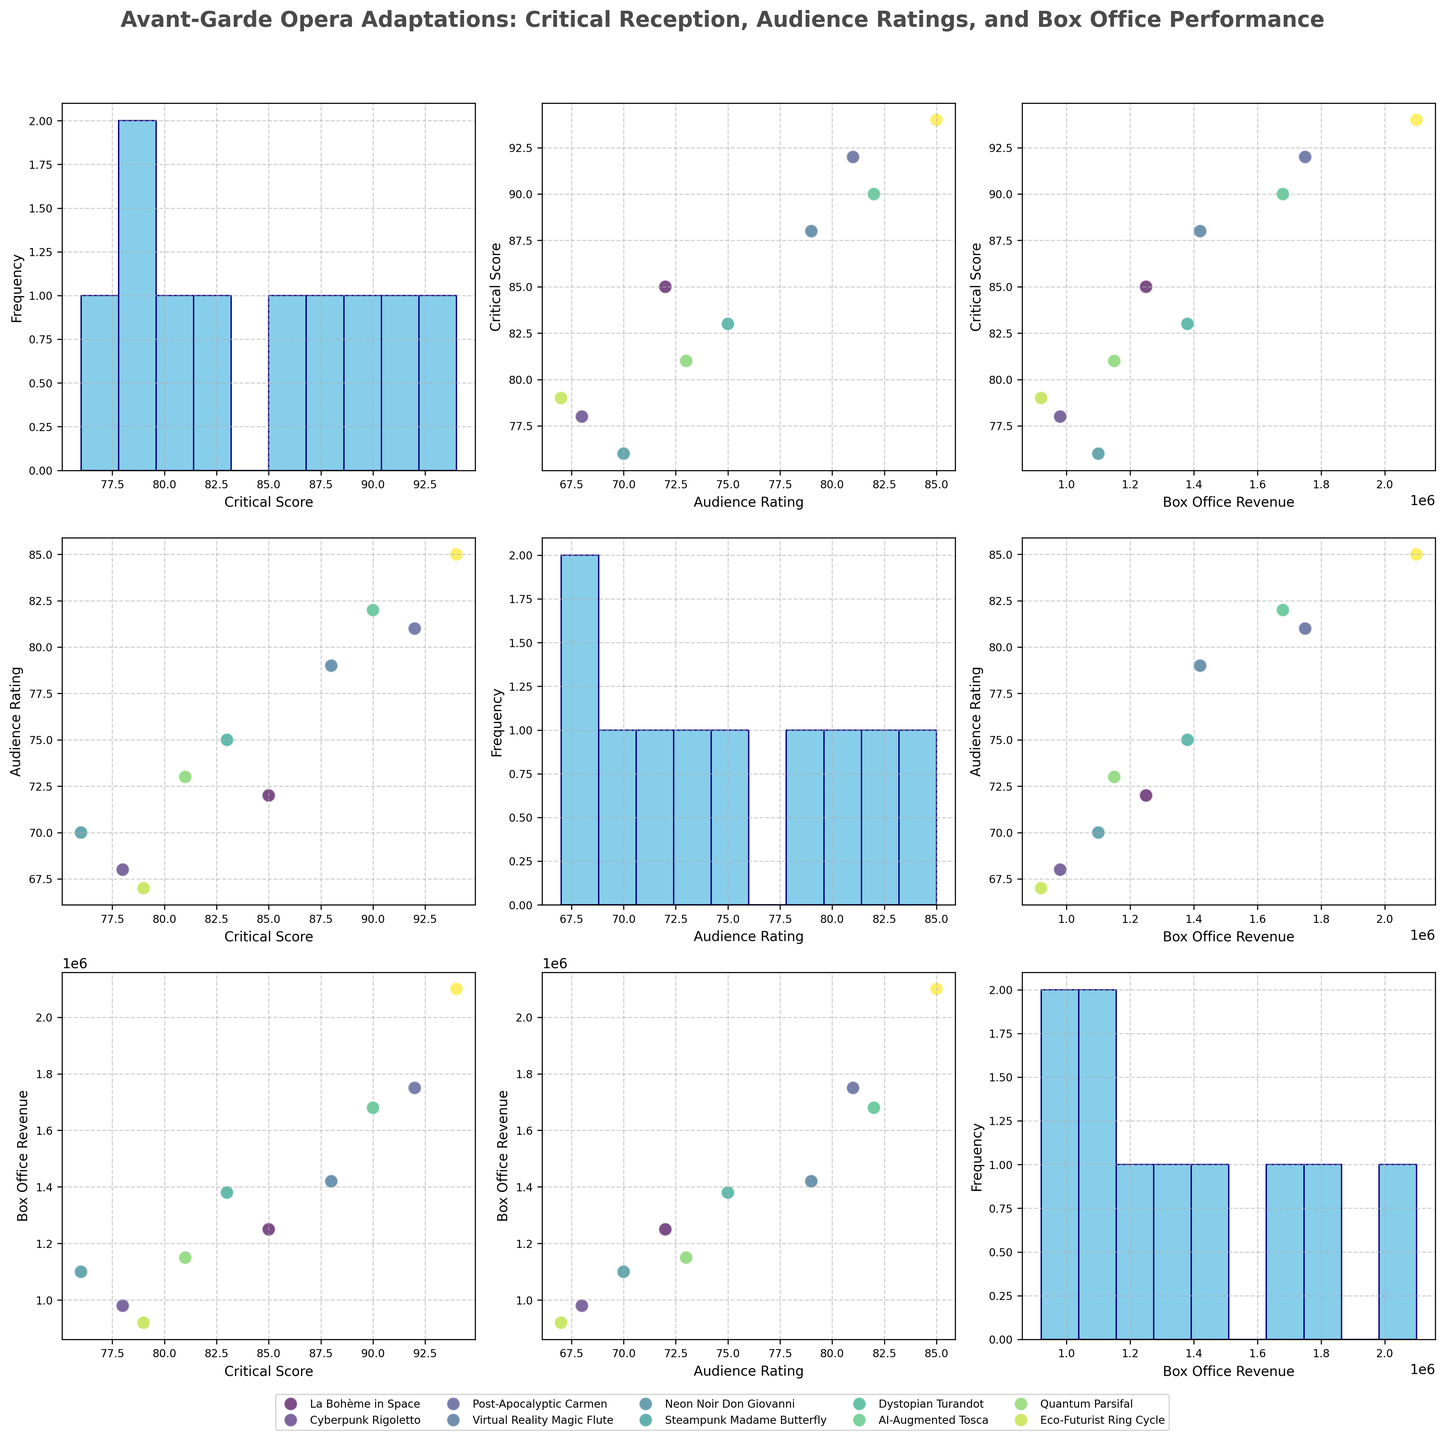What is the histogram plot in the diagonal of the scatterplot matrix representing? The histogram plots in the diagonal of the scatterplot matrix represent the frequency distribution of the individual variables, which in this case are Critical Score, Audience Rating, and Box Office Revenue.
Answer: Frequency distribution of individual variables How many operas have a Critical Score above 90? By examining the distribution of data points in the scatterplots where Critical Score is on the y-axis, we can see that "Post-Apocalyptic Carmen," "Dystopian Turandot," and "Eco-Futurist Ring Cycle" have Critical Scores above 90. Count these operas.
Answer: 3 Which opera has the highest Box Office Revenue and its corresponding Critical Score and Audience Rating? Locate the data point at the far right of the scatterplots where "Box Office Revenue" is on the x-axis. The highest Box Office Revenue is associated with "Eco-Futurist Ring Cycle" which has a Critical Score of 94 and an Audience Rating of 85.
Answer: Eco-Futurist Ring Cycle with Critical Score of 94 and Audience Rating of 85 Are there any operas with a Critical Score above 80 and Box Office Revenue below 1,000,000? Examine the scatterplots where Critical Score is on the y-axis and Box Office Revenue is on the x-axis, specifically looking for data points with Critical Scores above 80 and corresponding Box Office Revenue below 1,000,000.
Answer: No Which opera has the lowest Audience Rating and what are its Critical Score and Box Office Revenue? Find the lowest point in the Audience Rating axis across all relevant scatterplots. "Quantum Parsifal" has the lowest Audience Rating of 67, with a Critical Score of 79 and Box Office Revenue of 920,000.
Answer: Quantum Parsifal with Critical Score of 79 and Box Office Revenue of 920,000 Is there a positive correlation between Critical Score and Box Office Revenue? Look at the scatterplot with Critical Score on the y-axis and Box Office Revenue on the x-axis. Observe the trend of data points. The points generally slope upwards indicating a positive correlation.
Answer: Yes What is the average Audience Rating of all operas? Use the Audience Rating values from the data: (72 + 68 + 81 + 79 + 70 + 75 + 82 + 73 + 67 + 85) / 10. Calculate the sum and then divide by the number of values.
Answer: 75.2 How does Virtual Reality Magic Flute's Box Office Revenue compare to Cyberpunk Rigoletto's? Locate the data points for both operas by matching the titles to the points on the scatterplots. Virtual Reality Magic Flute has a Box Office Revenue of 1,420,000, which is higher than Cyberpunk Rigoletto's 980,000.
Answer: Higher Which opera has the smallest difference between Critical Score and Audience Rating? For each opera, subtract the Audience Rating from the Critical Score, and identify the opera with the smallest result. Calculations show that "La Bohème in Space" has a difference of (85-72=13), "Cyberpunk Rigoletto" (78-68=10), and so on. "Post-Apocalyptic Carmen" has the smallest difference (92-81=11).
Answer: Cyberpunk Rigoletto What is the range of Box Office Revenues among the operas? Identify the highest (Eco-Futurist Ring Cycle with 2,100,000) and lowest (Quantum Parsifal with 920,000) Box Office Revenues from the plots and find the difference.
Answer: 1,180,000 